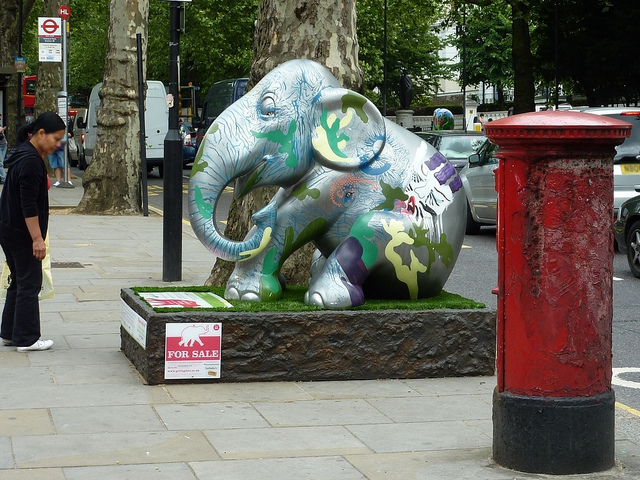Can you tell me about the artwork on the elephant sculpture? The elephant sculpture is adorned with a vibrant mosaic of colors and patterns, likely representing a collaboration of artistic expressions. The designs could symbolize cultural significance or raise awareness for elephant conservation. 